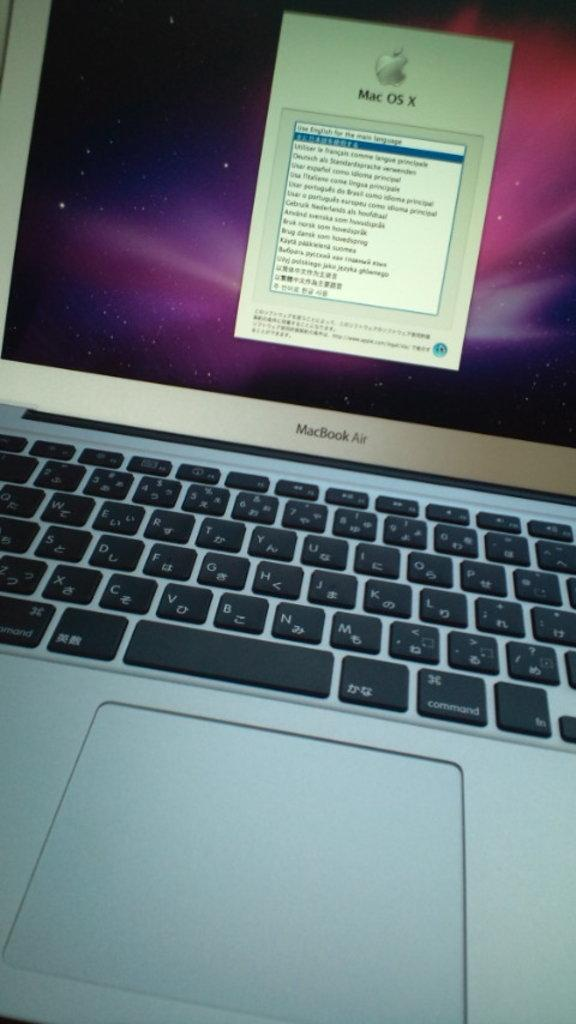<image>
Create a compact narrative representing the image presented. A silver mac laptop with black keys and a pop up that says Mac. 